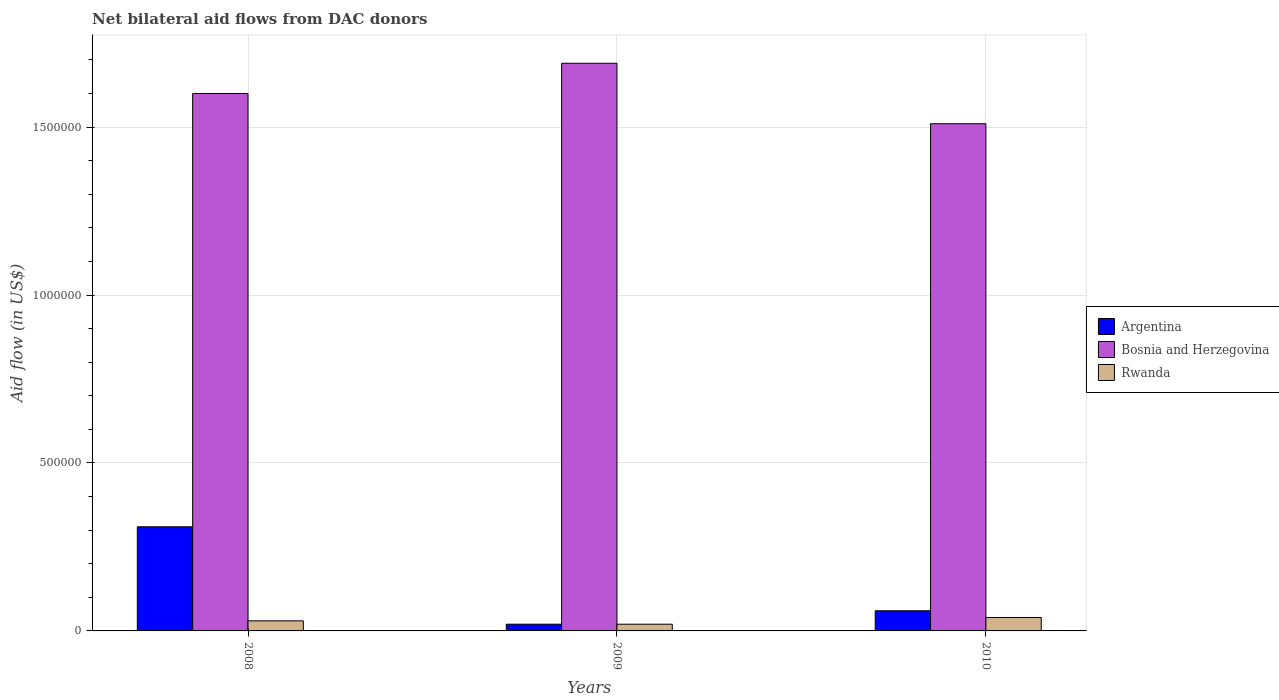How many groups of bars are there?
Your response must be concise. 3. How many bars are there on the 2nd tick from the right?
Ensure brevity in your answer.  3. What is the label of the 1st group of bars from the left?
Offer a terse response. 2008. What is the net bilateral aid flow in Bosnia and Herzegovina in 2009?
Offer a terse response. 1.69e+06. Across all years, what is the minimum net bilateral aid flow in Bosnia and Herzegovina?
Provide a succinct answer. 1.51e+06. In which year was the net bilateral aid flow in Argentina maximum?
Offer a terse response. 2008. What is the total net bilateral aid flow in Bosnia and Herzegovina in the graph?
Offer a very short reply. 4.80e+06. What is the difference between the net bilateral aid flow in Bosnia and Herzegovina in 2008 and that in 2009?
Keep it short and to the point. -9.00e+04. What is the difference between the net bilateral aid flow in Bosnia and Herzegovina in 2008 and the net bilateral aid flow in Rwanda in 2010?
Make the answer very short. 1.56e+06. What is the average net bilateral aid flow in Bosnia and Herzegovina per year?
Your answer should be very brief. 1.60e+06. In the year 2010, what is the difference between the net bilateral aid flow in Argentina and net bilateral aid flow in Bosnia and Herzegovina?
Keep it short and to the point. -1.45e+06. What is the ratio of the net bilateral aid flow in Rwanda in 2009 to that in 2010?
Ensure brevity in your answer.  0.5. What is the difference between the highest and the second highest net bilateral aid flow in Argentina?
Give a very brief answer. 2.50e+05. What is the difference between the highest and the lowest net bilateral aid flow in Argentina?
Provide a succinct answer. 2.90e+05. What does the 2nd bar from the left in 2009 represents?
Provide a succinct answer. Bosnia and Herzegovina. What does the 2nd bar from the right in 2008 represents?
Ensure brevity in your answer.  Bosnia and Herzegovina. What is the difference between two consecutive major ticks on the Y-axis?
Keep it short and to the point. 5.00e+05. Does the graph contain any zero values?
Give a very brief answer. No. Does the graph contain grids?
Provide a succinct answer. Yes. Where does the legend appear in the graph?
Your answer should be very brief. Center right. How are the legend labels stacked?
Offer a terse response. Vertical. What is the title of the graph?
Your answer should be compact. Net bilateral aid flows from DAC donors. Does "Uganda" appear as one of the legend labels in the graph?
Ensure brevity in your answer.  No. What is the label or title of the Y-axis?
Keep it short and to the point. Aid flow (in US$). What is the Aid flow (in US$) in Argentina in 2008?
Provide a succinct answer. 3.10e+05. What is the Aid flow (in US$) in Bosnia and Herzegovina in 2008?
Give a very brief answer. 1.60e+06. What is the Aid flow (in US$) of Rwanda in 2008?
Give a very brief answer. 3.00e+04. What is the Aid flow (in US$) of Bosnia and Herzegovina in 2009?
Your answer should be very brief. 1.69e+06. What is the Aid flow (in US$) of Argentina in 2010?
Ensure brevity in your answer.  6.00e+04. What is the Aid flow (in US$) of Bosnia and Herzegovina in 2010?
Offer a very short reply. 1.51e+06. What is the Aid flow (in US$) in Rwanda in 2010?
Ensure brevity in your answer.  4.00e+04. Across all years, what is the maximum Aid flow (in US$) in Argentina?
Provide a succinct answer. 3.10e+05. Across all years, what is the maximum Aid flow (in US$) in Bosnia and Herzegovina?
Provide a short and direct response. 1.69e+06. Across all years, what is the minimum Aid flow (in US$) of Argentina?
Ensure brevity in your answer.  2.00e+04. Across all years, what is the minimum Aid flow (in US$) of Bosnia and Herzegovina?
Ensure brevity in your answer.  1.51e+06. What is the total Aid flow (in US$) in Bosnia and Herzegovina in the graph?
Ensure brevity in your answer.  4.80e+06. What is the total Aid flow (in US$) of Rwanda in the graph?
Give a very brief answer. 9.00e+04. What is the difference between the Aid flow (in US$) of Argentina in 2008 and that in 2009?
Provide a short and direct response. 2.90e+05. What is the difference between the Aid flow (in US$) of Rwanda in 2008 and that in 2009?
Your response must be concise. 10000. What is the difference between the Aid flow (in US$) in Argentina in 2008 and that in 2010?
Your answer should be very brief. 2.50e+05. What is the difference between the Aid flow (in US$) of Bosnia and Herzegovina in 2009 and that in 2010?
Your response must be concise. 1.80e+05. What is the difference between the Aid flow (in US$) of Rwanda in 2009 and that in 2010?
Ensure brevity in your answer.  -2.00e+04. What is the difference between the Aid flow (in US$) in Argentina in 2008 and the Aid flow (in US$) in Bosnia and Herzegovina in 2009?
Your answer should be very brief. -1.38e+06. What is the difference between the Aid flow (in US$) in Bosnia and Herzegovina in 2008 and the Aid flow (in US$) in Rwanda in 2009?
Keep it short and to the point. 1.58e+06. What is the difference between the Aid flow (in US$) of Argentina in 2008 and the Aid flow (in US$) of Bosnia and Herzegovina in 2010?
Your answer should be compact. -1.20e+06. What is the difference between the Aid flow (in US$) in Bosnia and Herzegovina in 2008 and the Aid flow (in US$) in Rwanda in 2010?
Provide a short and direct response. 1.56e+06. What is the difference between the Aid flow (in US$) in Argentina in 2009 and the Aid flow (in US$) in Bosnia and Herzegovina in 2010?
Provide a succinct answer. -1.49e+06. What is the difference between the Aid flow (in US$) of Bosnia and Herzegovina in 2009 and the Aid flow (in US$) of Rwanda in 2010?
Your response must be concise. 1.65e+06. What is the average Aid flow (in US$) in Bosnia and Herzegovina per year?
Offer a very short reply. 1.60e+06. In the year 2008, what is the difference between the Aid flow (in US$) in Argentina and Aid flow (in US$) in Bosnia and Herzegovina?
Provide a short and direct response. -1.29e+06. In the year 2008, what is the difference between the Aid flow (in US$) of Argentina and Aid flow (in US$) of Rwanda?
Ensure brevity in your answer.  2.80e+05. In the year 2008, what is the difference between the Aid flow (in US$) in Bosnia and Herzegovina and Aid flow (in US$) in Rwanda?
Provide a short and direct response. 1.57e+06. In the year 2009, what is the difference between the Aid flow (in US$) in Argentina and Aid flow (in US$) in Bosnia and Herzegovina?
Your answer should be compact. -1.67e+06. In the year 2009, what is the difference between the Aid flow (in US$) of Bosnia and Herzegovina and Aid flow (in US$) of Rwanda?
Make the answer very short. 1.67e+06. In the year 2010, what is the difference between the Aid flow (in US$) of Argentina and Aid flow (in US$) of Bosnia and Herzegovina?
Provide a short and direct response. -1.45e+06. In the year 2010, what is the difference between the Aid flow (in US$) in Bosnia and Herzegovina and Aid flow (in US$) in Rwanda?
Keep it short and to the point. 1.47e+06. What is the ratio of the Aid flow (in US$) in Argentina in 2008 to that in 2009?
Your answer should be compact. 15.5. What is the ratio of the Aid flow (in US$) of Bosnia and Herzegovina in 2008 to that in 2009?
Provide a short and direct response. 0.95. What is the ratio of the Aid flow (in US$) in Argentina in 2008 to that in 2010?
Your response must be concise. 5.17. What is the ratio of the Aid flow (in US$) of Bosnia and Herzegovina in 2008 to that in 2010?
Provide a succinct answer. 1.06. What is the ratio of the Aid flow (in US$) in Argentina in 2009 to that in 2010?
Your answer should be compact. 0.33. What is the ratio of the Aid flow (in US$) in Bosnia and Herzegovina in 2009 to that in 2010?
Provide a succinct answer. 1.12. What is the difference between the highest and the second highest Aid flow (in US$) of Bosnia and Herzegovina?
Your answer should be very brief. 9.00e+04. What is the difference between the highest and the second highest Aid flow (in US$) of Rwanda?
Keep it short and to the point. 10000. What is the difference between the highest and the lowest Aid flow (in US$) of Argentina?
Provide a succinct answer. 2.90e+05. What is the difference between the highest and the lowest Aid flow (in US$) of Rwanda?
Your answer should be very brief. 2.00e+04. 